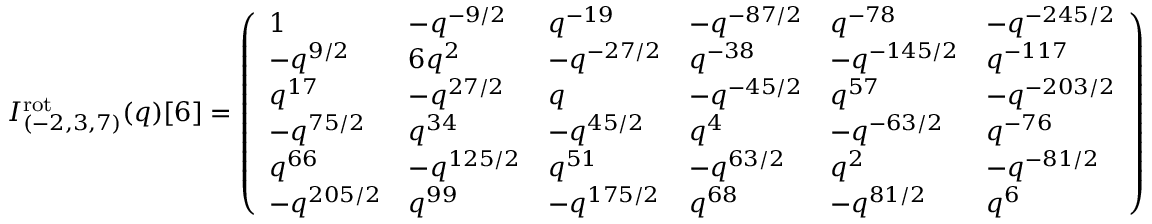<formula> <loc_0><loc_0><loc_500><loc_500>I _ { ( - 2 , 3 , 7 ) } ^ { r o t } ( q ) [ 6 ] = \left ( \begin{array} { l l l l l l } { 1 } & { - q ^ { - 9 / 2 } } & { q ^ { - 1 9 } } & { - q ^ { - 8 7 / 2 } } & { q ^ { - 7 8 } } & { - q ^ { - 2 4 5 / 2 } } \\ { - q ^ { 9 / 2 } } & { 6 q ^ { 2 } } & { - q ^ { - 2 7 / 2 } } & { q ^ { - 3 8 } } & { - q ^ { - 1 4 5 / 2 } } & { q ^ { - 1 1 7 } } \\ { q ^ { 1 7 } } & { - q ^ { 2 7 / 2 } } & { q } & { - q ^ { - 4 5 / 2 } } & { q ^ { 5 7 } } & { - q ^ { - 2 0 3 / 2 } } \\ { - q ^ { 7 5 / 2 } } & { q ^ { 3 4 } } & { - q ^ { 4 5 / 2 } } & { q ^ { 4 } } & { - q ^ { - 6 3 / 2 } } & { q ^ { - 7 6 } } \\ { q ^ { 6 6 } } & { - q ^ { 1 2 5 / 2 } } & { q ^ { 5 1 } } & { - q ^ { 6 3 / 2 } } & { q ^ { 2 } } & { - q ^ { - 8 1 / 2 } } \\ { - q ^ { 2 0 5 / 2 } } & { q ^ { 9 9 } } & { - q ^ { 1 7 5 / 2 } } & { q ^ { 6 8 } } & { - q ^ { 8 1 / 2 } } & { q ^ { 6 } } \end{array} \right )</formula> 